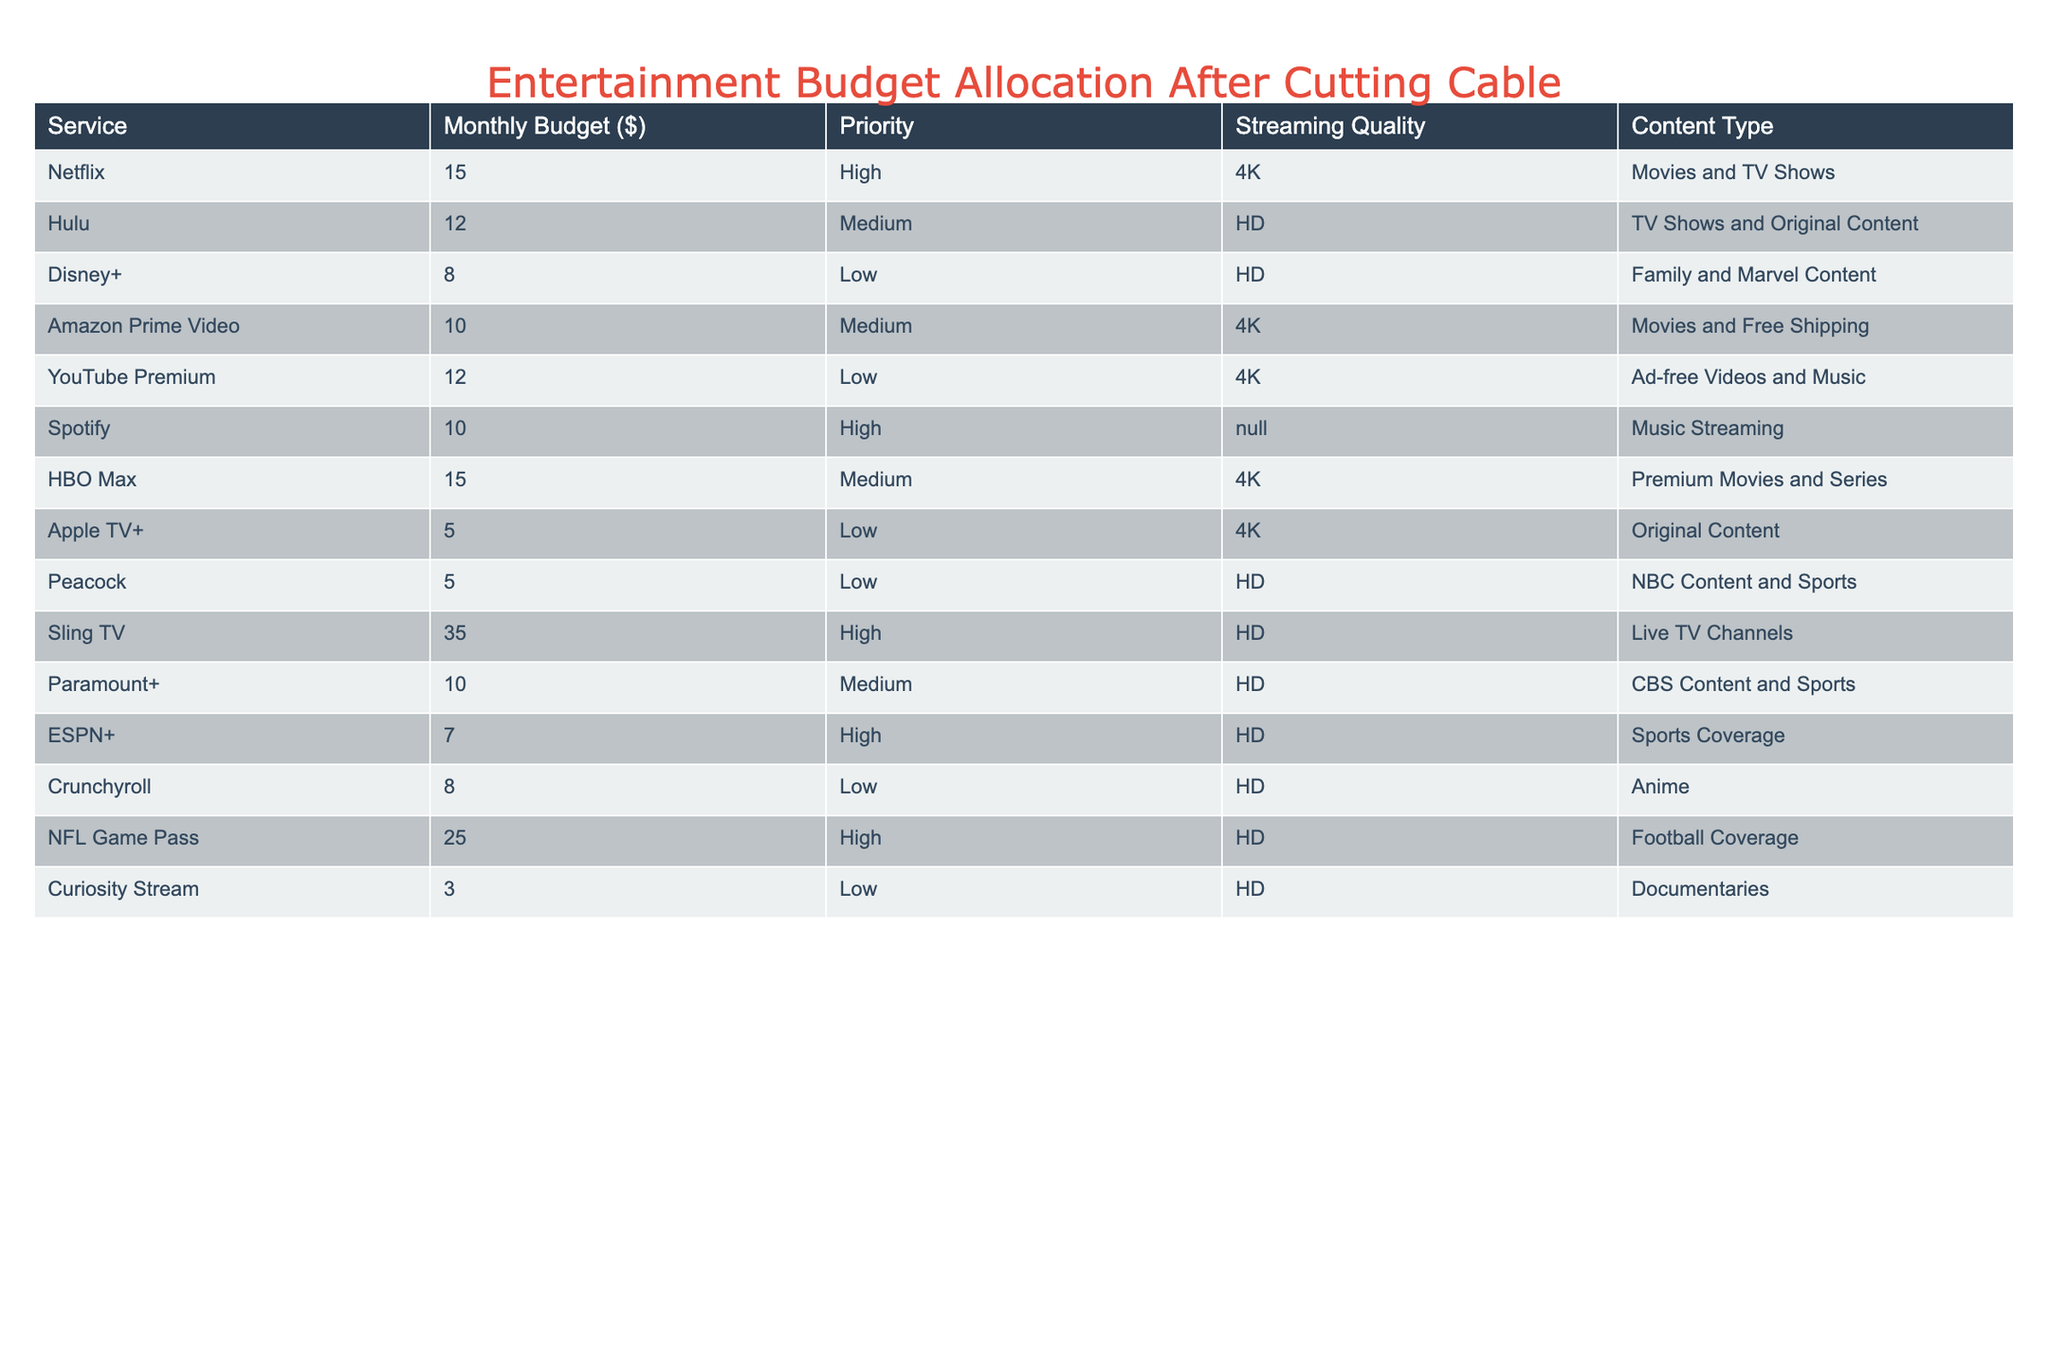What is the monthly budget allocated for Netflix? According to the table, Netflix has a specified monthly budget of $15.
Answer: 15 Which service has the highest priority and costs $35? Sling TV is the only service in the table that has a high priority level and costs $35.
Answer: Yes How many services are allocated a budget of $10 or more? The services with budgets of $10 or more are Netflix ($15), Hulu ($12), Amazon Prime Video ($10), Sling TV ($35), HBO Max ($15), ESPN+ ($7, but not included), and Paramount+ ($10). There are six services overall.
Answer: 6 What is the total monthly budget for all high-priority services? To find the total, we sum the budgets of all high-priority services: Netflix ($15) + Sling TV ($35) + Spotify ($10) + ESPN+ ($7) + NFL Game Pass ($25) = $92.
Answer: 92 Is there any service that provides content in 4K and has a low priority? The only service with a low priority that offers 4K content is YouTube Premium.
Answer: Yes What is the average monthly budget of all the services listed? First, we add up all the monthly budgets: 15 + 12 + 8 + 10 + 12 + 10 + 15 + 5 + 5 + 35 + 10 + 7 + 8 + 25 + 3 = $16.67. Since there are 15 services, $160/15 = $10.67.
Answer: 10.67 Which services are categorized as medium priority and have an HD streaming quality? The services with medium priority and HD streaming quality are Hulu ($12), HBO Max ($15), and Paramount+ ($10).
Answer: Hulu, HBO Max, and Paramount+ What is the combined streaming budget for family and marvel content in low-priority services? The only service in the low-priority category that provides family and marvel content is Disney+ with a budget of $8. Therefore, the combined budget is $8.
Answer: 8 